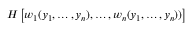Convert formula to latex. <formula><loc_0><loc_0><loc_500><loc_500>H \left [ w _ { 1 } ( y _ { 1 } , \dots , y _ { n } ) , \dots , w _ { n } ( y _ { 1 } , \dots , y _ { n } ) ) \right ]</formula> 